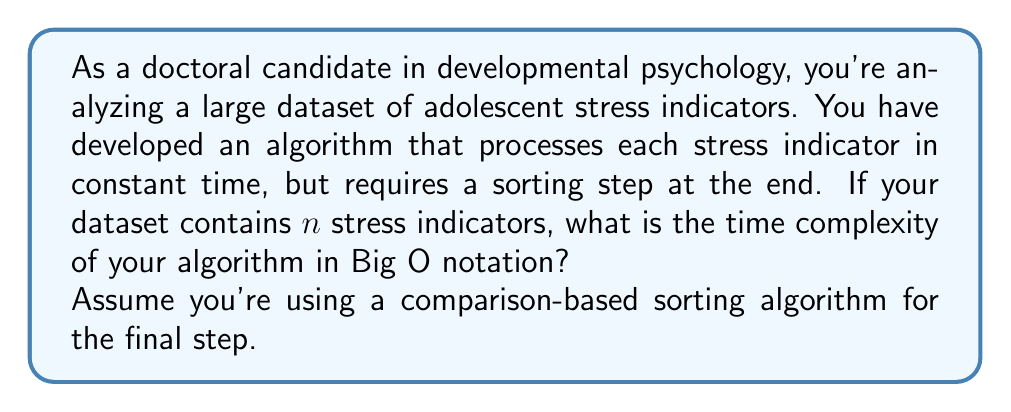Can you answer this question? Let's break this down step by step:

1) Processing each stress indicator:
   - You have $n$ indicators, and each is processed in constant time.
   - This step has a time complexity of $O(n)$.

2) Sorting step:
   - You're using a comparison-based sorting algorithm.
   - The best time complexity for comparison-based sorting algorithms is $O(n \log n)$.

3) Total time complexity:
   - The total time is the sum of the processing time and the sorting time.
   - In Big O notation, we only consider the dominant term.
   - $O(n) + O(n \log n) = O(n \log n)$

The $O(n \log n)$ term dominates because it grows faster than $O(n)$ as $n$ increases.

In the context of your research, this means that as your dataset of adolescent stress indicators grows larger, the time your algorithm takes will grow slightly faster than linearly, but not as fast as quadratically. This is generally considered a reasonably efficient algorithm for large datasets.

However, if you're dealing with extremely large datasets, you might want to consider whether sorting is necessary for your analysis, or if there are alternative methods that could avoid this $n \log n$ complexity.
Answer: $O(n \log n)$ 